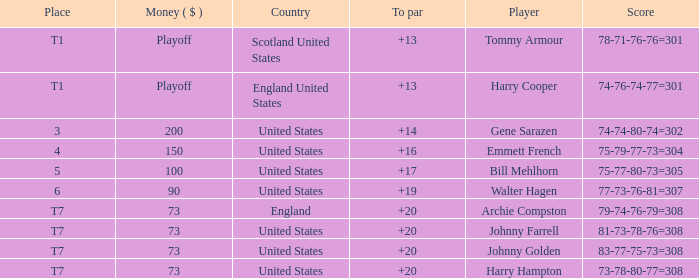What is the ranking when Archie Compston is the player and the money is $73? T7. 